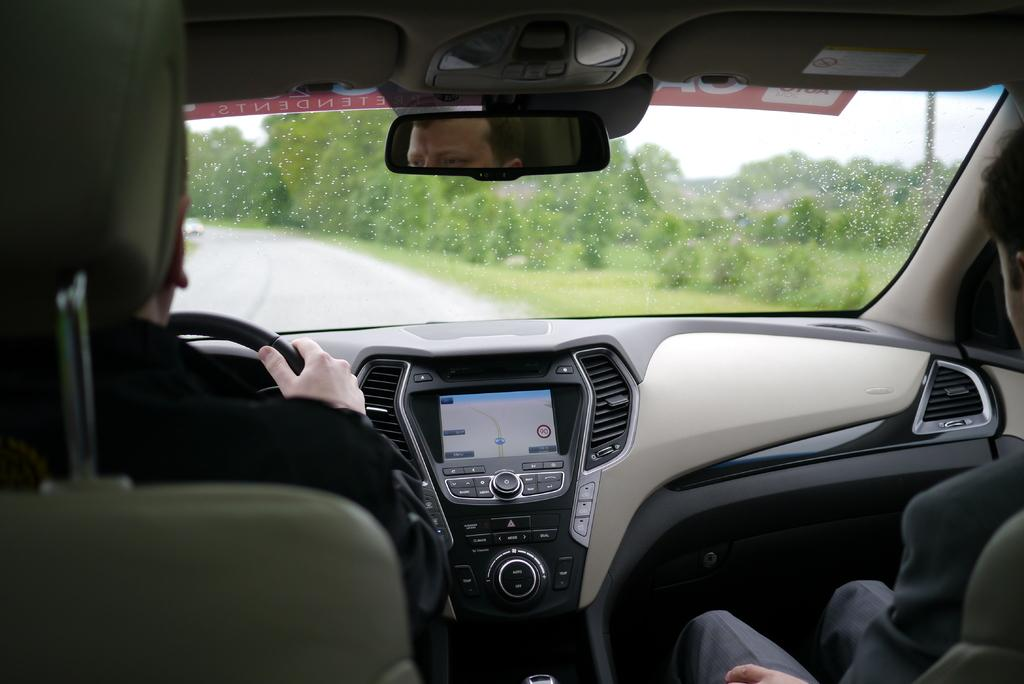What is the setting of the image? The image shows the inside view of a car. What part of the car is visible in the image? The car's dashboard is visible in the image. How many people are in the car? There are two persons in the car. What can be seen through the front of the car? The windshield is visible in the image. What type of vegetation is visible in the background of the image? There are trees and plants in the background of the image. Can you tell me how many toes the person in the driver's seat has? There is no information about the number of toes of the person in the driver's seat, as the image only shows the inside of the car and not the feet of the individuals. 